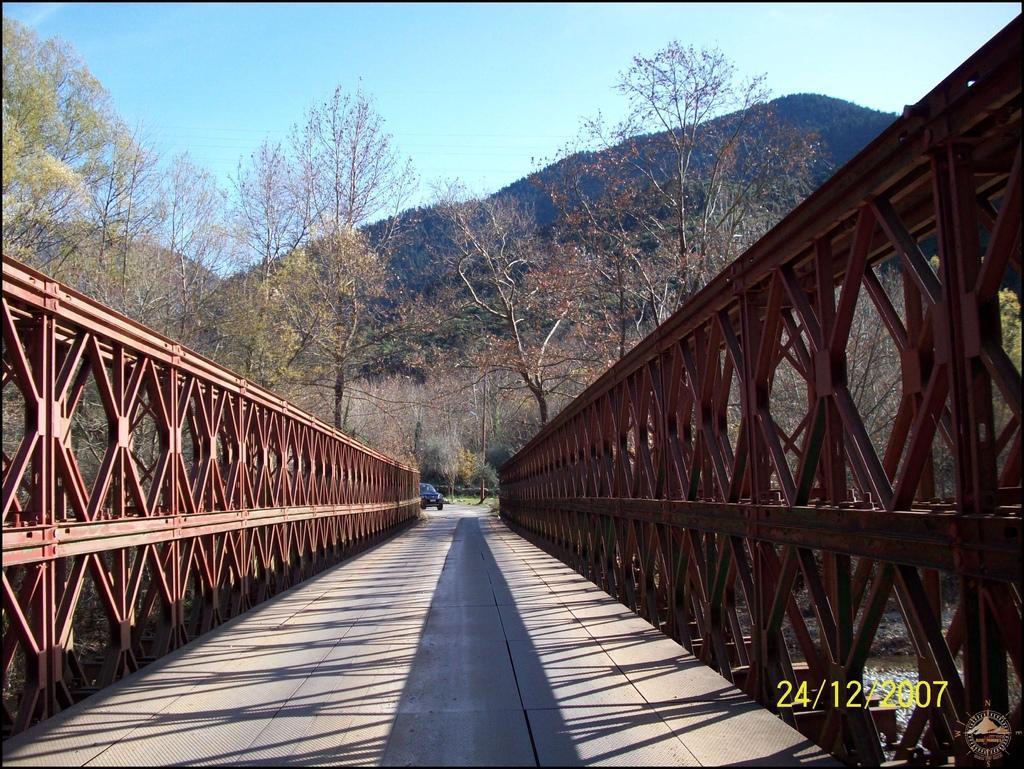In one or two sentences, can you explain what this image depicts? In this image we can see a bridge and a vehicle on the ground. There are trees, mountain and sky in the background. 